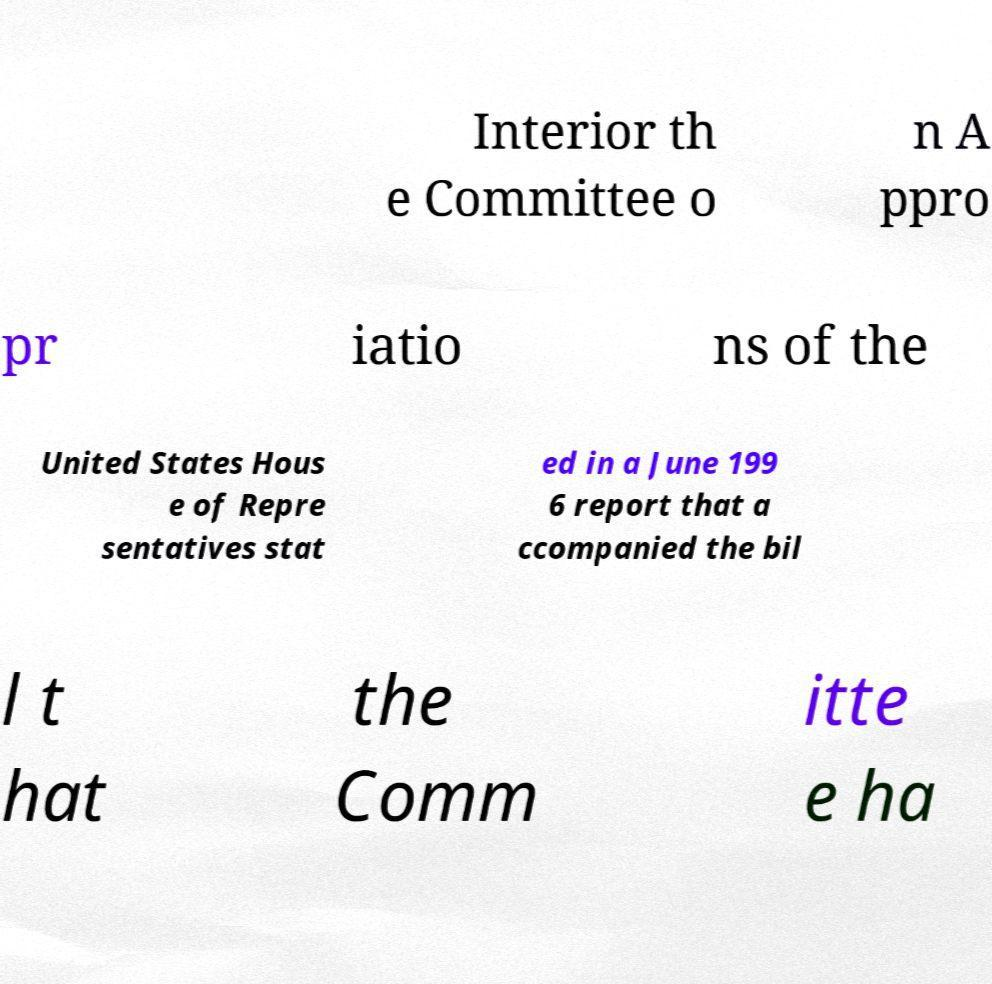Could you assist in decoding the text presented in this image and type it out clearly? Interior th e Committee o n A ppro pr iatio ns of the United States Hous e of Repre sentatives stat ed in a June 199 6 report that a ccompanied the bil l t hat the Comm itte e ha 